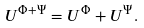<formula> <loc_0><loc_0><loc_500><loc_500>U ^ { \Phi + \Psi } = U ^ { \Phi } + U ^ { \Psi } .</formula> 